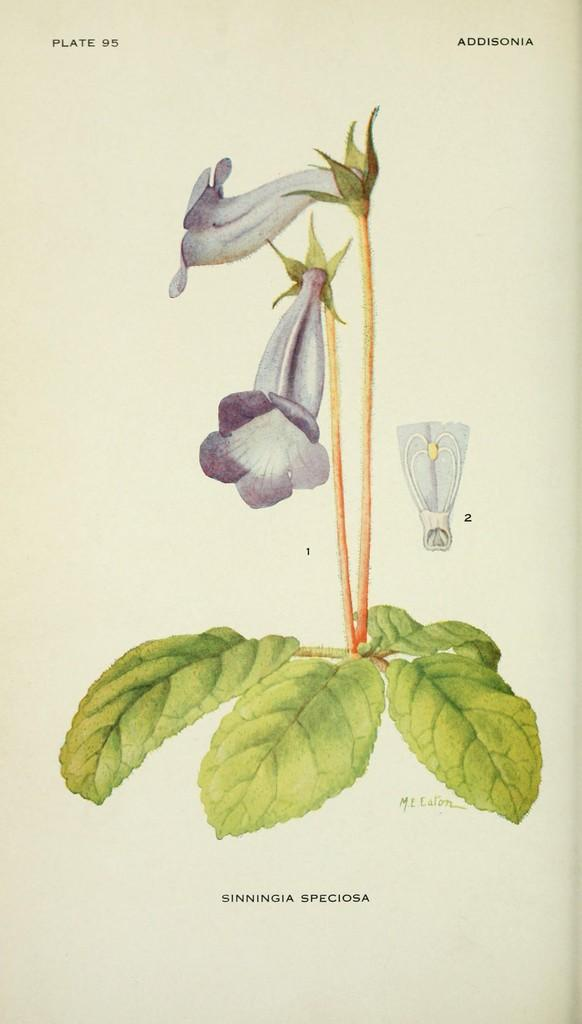What type of artwork is depicted in the image? The image is a drawing. What kind of flora can be seen in the drawing? There are flowers and a plant in the drawing. What type of whip is being used to water the plant in the drawing? There is no whip present in the drawing; it is a plant and flowers in a drawing. 